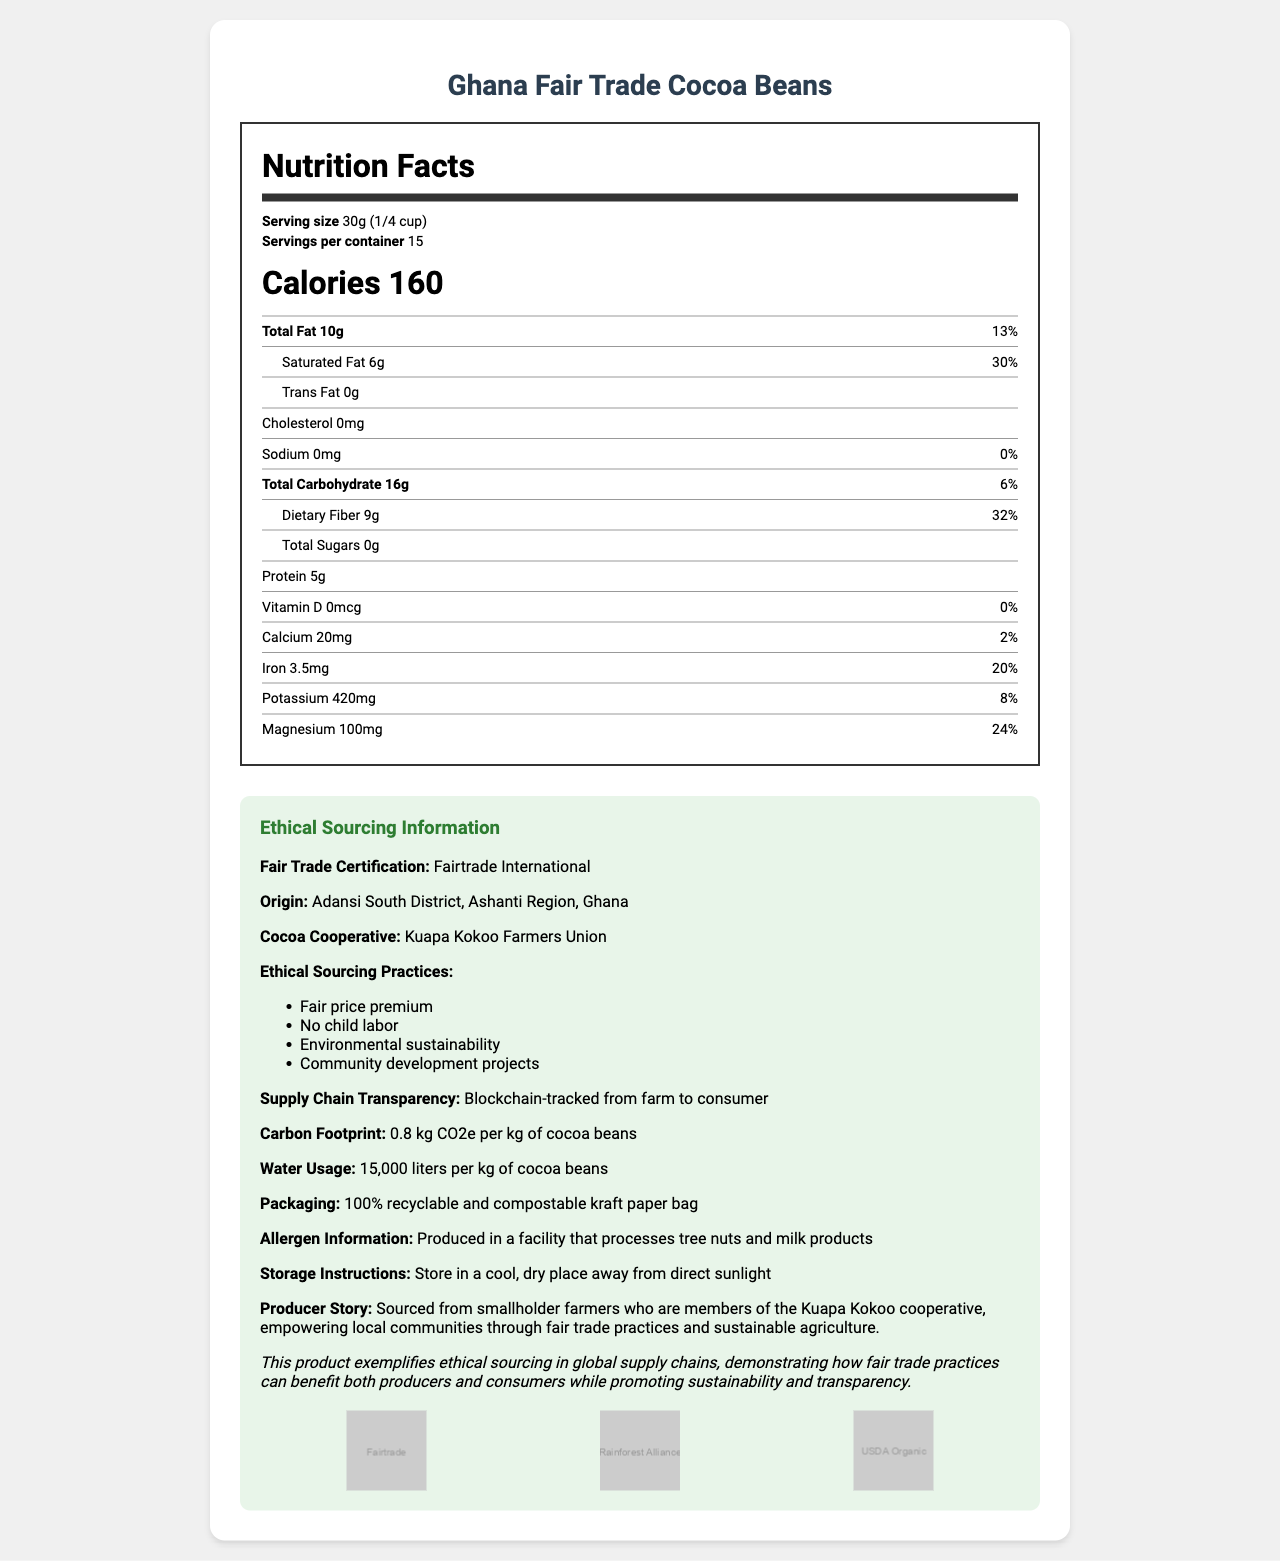what is the serving size of Ghana Fair Trade Cocoa Beans? The serving size is explicitly mentioned under the serving information as "30g (1/4 cup)".
Answer: 30g (1/4 cup) how many calories are in one serving of Ghana Fair Trade Cocoa Beans? The document specifies the calorie content as "Calories 160".
Answer: 160 what is the daily value percentage of dietary fiber per serving? The daily value percentage for dietary fiber is labeled as "32%" next to the amount of dietary fiber.
Answer: 32% mention two ethical sourcing practices listed for Ghana Fair Trade Cocoa Beans. The ethical sourcing practices are listed in the document, including "Fair price premium" and "No child labor".
Answer: Fair price premium, No child labor what is the carbon footprint per kg of cocoa beans? The carbon footprint information is found under the ethical sourcing section as "0.8 kg CO2e per kg of cocoa beans".
Answer: 0.8 kg CO2e what organization certifies the fair trade of these cocoa beans? A. Fairtrade International B. Rainforest Alliance C. USDA Organic D. UTZ The document states that the Fair Trade Certification is provided by "Fairtrade International".
Answer: A which nutrient has the highest daily value percentage other than dietary fiber? A. Total Fat B. Iron C. Magnesium D. Saturated Fat Saturated fat has a daily value of "30%", which is the highest after dietary fiber's 32%.
Answer: D are these cocoa beans produced in a facility that processes tree nuts? According to the allergen information, the product is produced in a facility that processes tree nuts and milk products.
Answer: Yes summarize the main ethical aspect of Ghana Fair Trade Cocoa Beans. The document highlights fair trade certification, sustainable agriculture, community projects, and transparent supply chains as the main ethical aspects.
Answer: Ethical sourcing with fair trade practices benefiting producers and sustainability. what is the exact origin location of the cocoa beans? The document mentions the origin as "Adansi South District, Ashanti Region, Ghana", but the precise geographical coordinates or detailed location within that region aren't provided.
Answer: Cannot be determined 